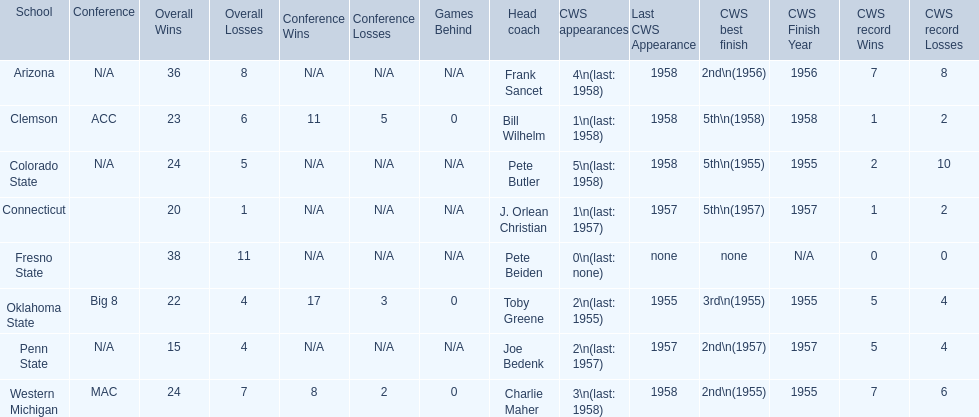Which school has no cws appearances? Fresno State. 